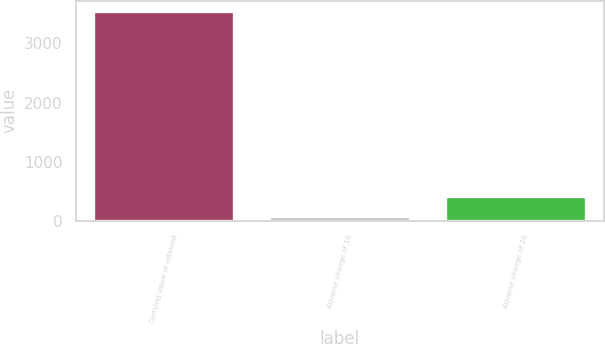Convert chart. <chart><loc_0><loc_0><loc_500><loc_500><bar_chart><fcel>Carrying value of retained<fcel>Adverse change of 10<fcel>Adverse change of 20<nl><fcel>3546<fcel>79<fcel>425.7<nl></chart> 